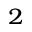<formula> <loc_0><loc_0><loc_500><loc_500>_ { 2 }</formula> 